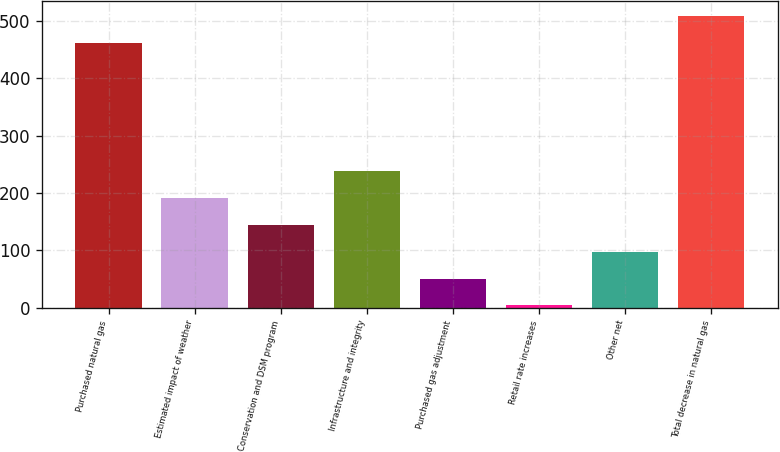Convert chart to OTSL. <chart><loc_0><loc_0><loc_500><loc_500><bar_chart><fcel>Purchased natural gas<fcel>Estimated impact of weather<fcel>Conservation and DSM program<fcel>Infrastructure and integrity<fcel>Purchased gas adjustment<fcel>Retail rate increases<fcel>Other net<fcel>Total decrease in natural gas<nl><fcel>462<fcel>190.8<fcel>144.1<fcel>237.5<fcel>50.7<fcel>4<fcel>97.4<fcel>508.7<nl></chart> 